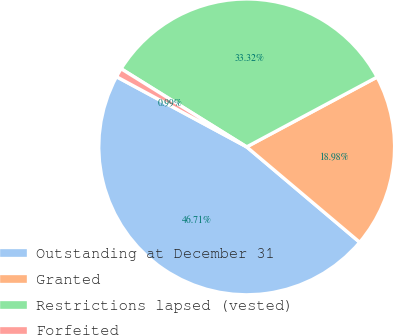<chart> <loc_0><loc_0><loc_500><loc_500><pie_chart><fcel>Outstanding at December 31<fcel>Granted<fcel>Restrictions lapsed (vested)<fcel>Forfeited<nl><fcel>46.71%<fcel>18.98%<fcel>33.32%<fcel>0.99%<nl></chart> 